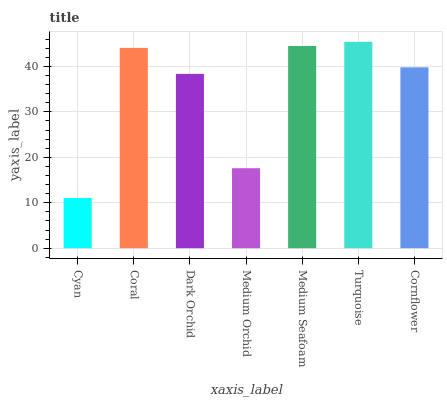Is Cyan the minimum?
Answer yes or no. Yes. Is Turquoise the maximum?
Answer yes or no. Yes. Is Coral the minimum?
Answer yes or no. No. Is Coral the maximum?
Answer yes or no. No. Is Coral greater than Cyan?
Answer yes or no. Yes. Is Cyan less than Coral?
Answer yes or no. Yes. Is Cyan greater than Coral?
Answer yes or no. No. Is Coral less than Cyan?
Answer yes or no. No. Is Cornflower the high median?
Answer yes or no. Yes. Is Cornflower the low median?
Answer yes or no. Yes. Is Coral the high median?
Answer yes or no. No. Is Medium Seafoam the low median?
Answer yes or no. No. 